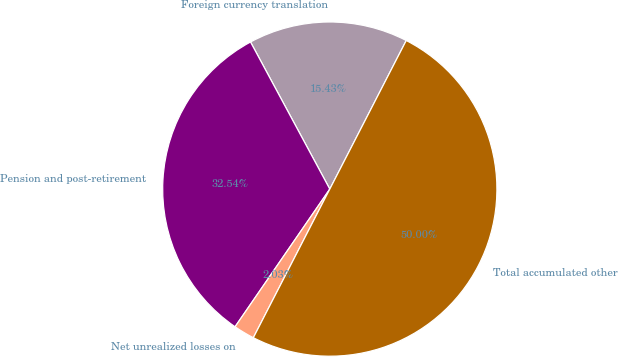Convert chart to OTSL. <chart><loc_0><loc_0><loc_500><loc_500><pie_chart><fcel>Foreign currency translation<fcel>Pension and post-retirement<fcel>Net unrealized losses on<fcel>Total accumulated other<nl><fcel>15.43%<fcel>32.54%<fcel>2.03%<fcel>50.0%<nl></chart> 